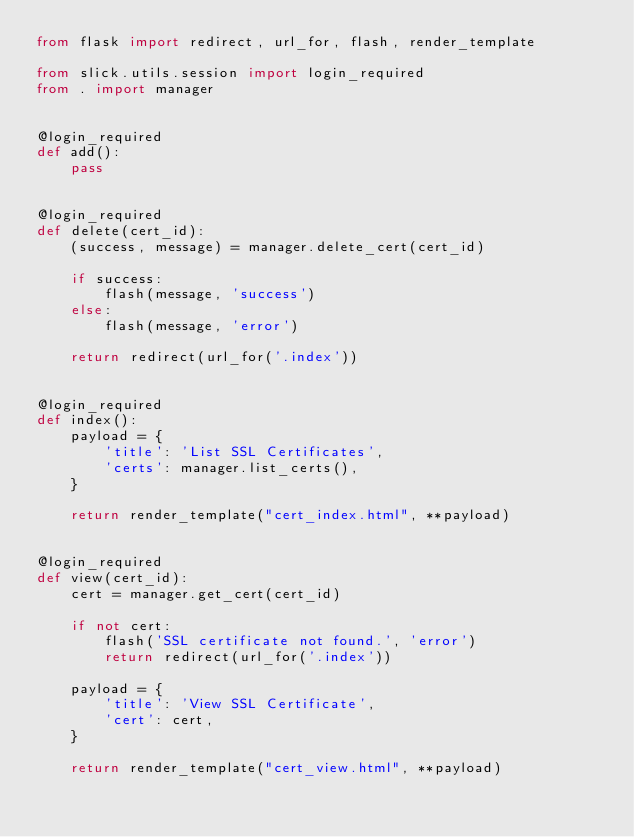Convert code to text. <code><loc_0><loc_0><loc_500><loc_500><_Python_>from flask import redirect, url_for, flash, render_template

from slick.utils.session import login_required
from . import manager


@login_required
def add():
    pass


@login_required
def delete(cert_id):
    (success, message) = manager.delete_cert(cert_id)

    if success:
        flash(message, 'success')
    else:
        flash(message, 'error')

    return redirect(url_for('.index'))


@login_required
def index():
    payload = {
        'title': 'List SSL Certificates',
        'certs': manager.list_certs(),
    }

    return render_template("cert_index.html", **payload)


@login_required
def view(cert_id):
    cert = manager.get_cert(cert_id)

    if not cert:
        flash('SSL certificate not found.', 'error')
        return redirect(url_for('.index'))

    payload = {
        'title': 'View SSL Certificate',
        'cert': cert,
    }

    return render_template("cert_view.html", **payload)
</code> 